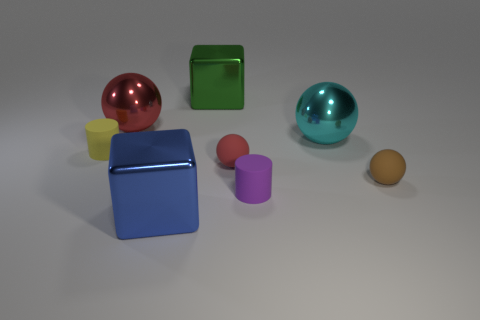There is a big green object that is the same shape as the blue thing; what material is it?
Your answer should be compact. Metal. How many other things are there of the same shape as the red metallic thing?
Make the answer very short. 3. There is a metal cube left of the large green metallic object; is its size the same as the matte cylinder that is on the right side of the large blue shiny thing?
Provide a short and direct response. No. There is a red metal object; is its size the same as the matte object that is left of the blue object?
Offer a terse response. No. What size is the sphere that is both in front of the cyan shiny ball and left of the cyan metallic object?
Your answer should be very brief. Small. Are there fewer green objects on the left side of the large cyan shiny thing than shiny spheres that are behind the big red metal ball?
Keep it short and to the point. No. Do the blue block and the cyan sphere have the same size?
Ensure brevity in your answer.  Yes. There is a shiny thing that is both to the right of the blue shiny object and to the left of the cyan ball; what is its shape?
Provide a short and direct response. Cube. What number of tiny red spheres have the same material as the cyan ball?
Offer a very short reply. 0. What number of big red shiny spheres are on the right side of the matte sphere behind the small brown object?
Give a very brief answer. 0. 